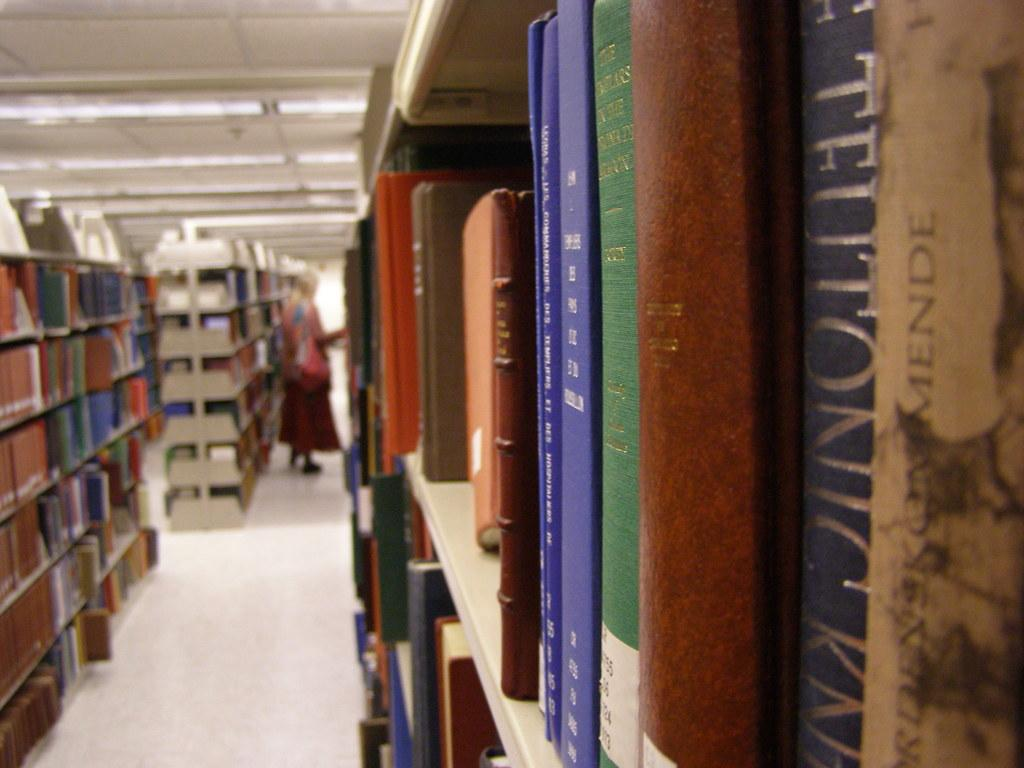What can be seen on the shelves in the image? There are books on the shelves in the image. What is written or printed on the books? The books have text and numbers on them. Who or what is standing on the floor in the image? There is a person standing on the floor in the image. What is providing light in the image? There are lights visible on top in the image. How far away is the cart from the bookshelf in the image? There is no cart present in the image, so it is not possible to determine the distance between a cart and the bookshelf. 